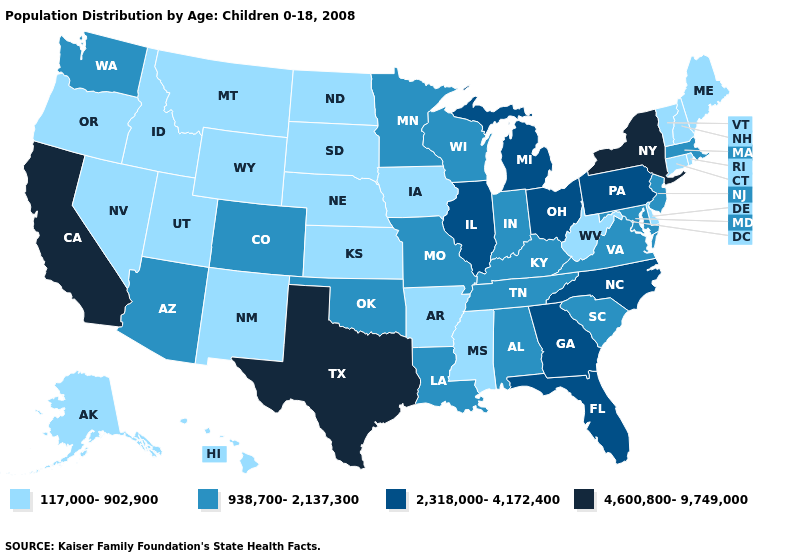Name the states that have a value in the range 2,318,000-4,172,400?
Keep it brief. Florida, Georgia, Illinois, Michigan, North Carolina, Ohio, Pennsylvania. What is the value of Illinois?
Give a very brief answer. 2,318,000-4,172,400. Among the states that border Idaho , which have the highest value?
Be succinct. Washington. Does the map have missing data?
Keep it brief. No. Among the states that border Kansas , which have the highest value?
Give a very brief answer. Colorado, Missouri, Oklahoma. Which states have the lowest value in the USA?
Short answer required. Alaska, Arkansas, Connecticut, Delaware, Hawaii, Idaho, Iowa, Kansas, Maine, Mississippi, Montana, Nebraska, Nevada, New Hampshire, New Mexico, North Dakota, Oregon, Rhode Island, South Dakota, Utah, Vermont, West Virginia, Wyoming. Name the states that have a value in the range 2,318,000-4,172,400?
Give a very brief answer. Florida, Georgia, Illinois, Michigan, North Carolina, Ohio, Pennsylvania. What is the highest value in the USA?
Write a very short answer. 4,600,800-9,749,000. Name the states that have a value in the range 938,700-2,137,300?
Keep it brief. Alabama, Arizona, Colorado, Indiana, Kentucky, Louisiana, Maryland, Massachusetts, Minnesota, Missouri, New Jersey, Oklahoma, South Carolina, Tennessee, Virginia, Washington, Wisconsin. What is the lowest value in the USA?
Answer briefly. 117,000-902,900. Does the first symbol in the legend represent the smallest category?
Quick response, please. Yes. What is the lowest value in the USA?
Answer briefly. 117,000-902,900. Does Alaska have the highest value in the USA?
Give a very brief answer. No. What is the value of Arkansas?
Quick response, please. 117,000-902,900. 